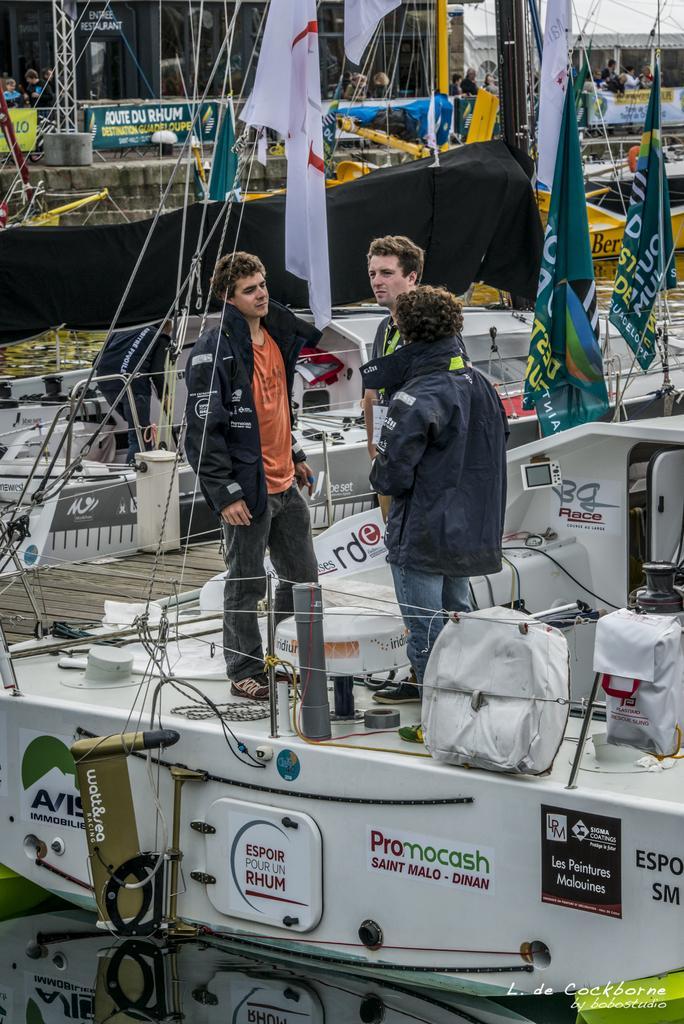Describe this image in one or two sentences. In this picture we can see few boats, flags and group of people, in the bottom right hand corner we can see some text. 